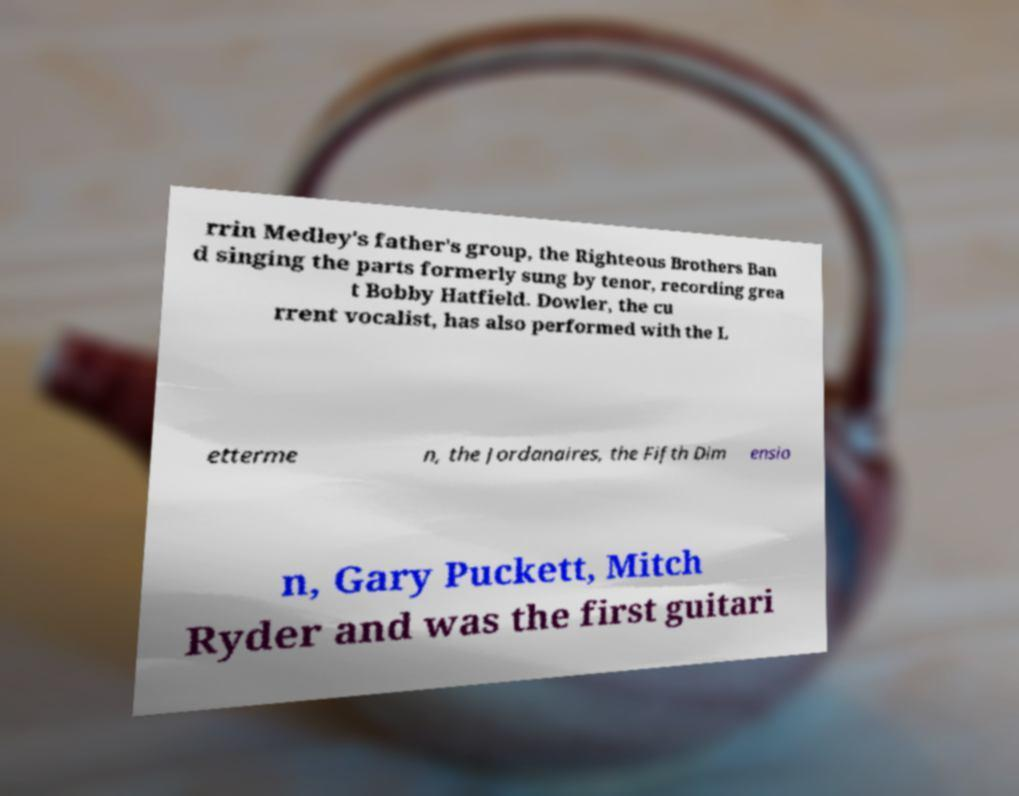Could you assist in decoding the text presented in this image and type it out clearly? rrin Medley's father's group, the Righteous Brothers Ban d singing the parts formerly sung by tenor, recording grea t Bobby Hatfield. Dowler, the cu rrent vocalist, has also performed with the L etterme n, the Jordanaires, the Fifth Dim ensio n, Gary Puckett, Mitch Ryder and was the first guitari 